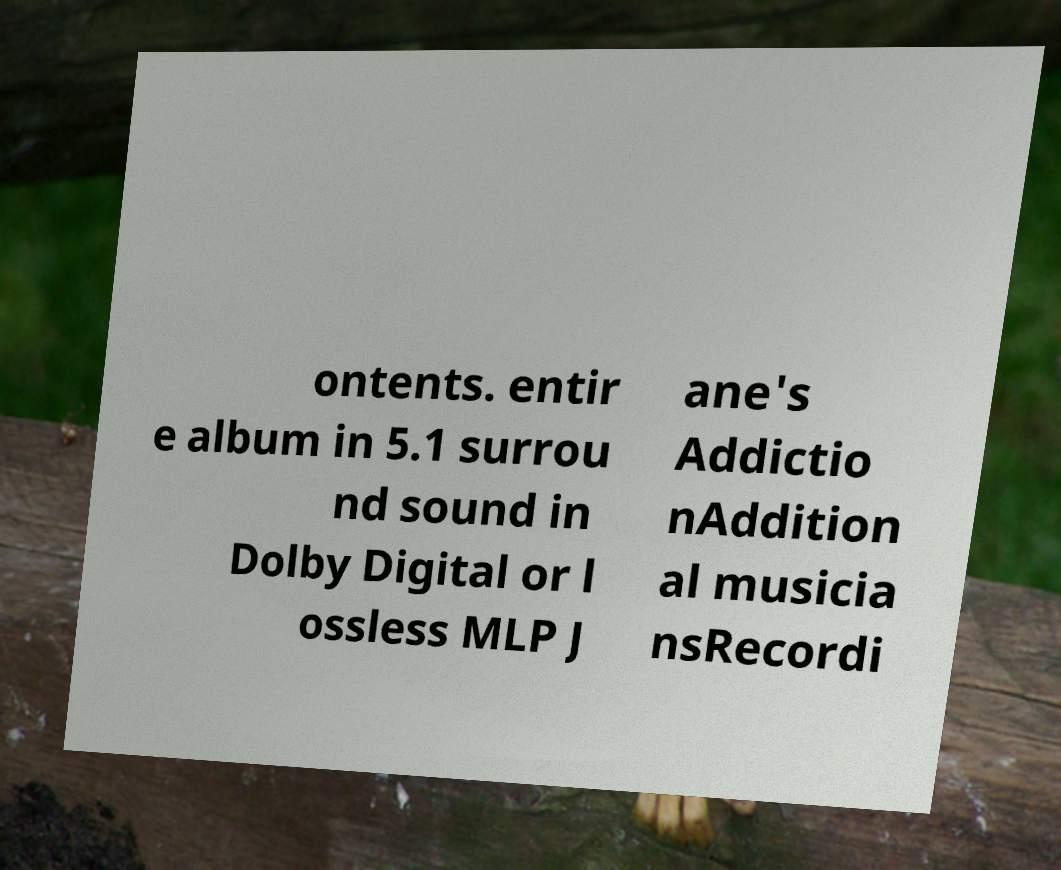Could you assist in decoding the text presented in this image and type it out clearly? ontents. entir e album in 5.1 surrou nd sound in Dolby Digital or l ossless MLP J ane's Addictio nAddition al musicia nsRecordi 